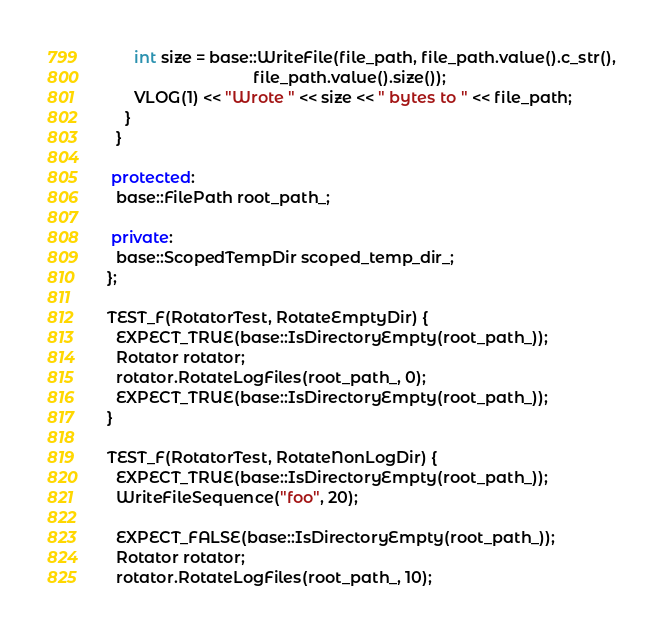Convert code to text. <code><loc_0><loc_0><loc_500><loc_500><_C++_>      int size = base::WriteFile(file_path, file_path.value().c_str(),
                                 file_path.value().size());
      VLOG(1) << "Wrote " << size << " bytes to " << file_path;
    }
  }

 protected:
  base::FilePath root_path_;

 private:
  base::ScopedTempDir scoped_temp_dir_;
};

TEST_F(RotatorTest, RotateEmptyDir) {
  EXPECT_TRUE(base::IsDirectoryEmpty(root_path_));
  Rotator rotator;
  rotator.RotateLogFiles(root_path_, 0);
  EXPECT_TRUE(base::IsDirectoryEmpty(root_path_));
}

TEST_F(RotatorTest, RotateNonLogDir) {
  EXPECT_TRUE(base::IsDirectoryEmpty(root_path_));
  WriteFileSequence("foo", 20);

  EXPECT_FALSE(base::IsDirectoryEmpty(root_path_));
  Rotator rotator;
  rotator.RotateLogFiles(root_path_, 10);</code> 